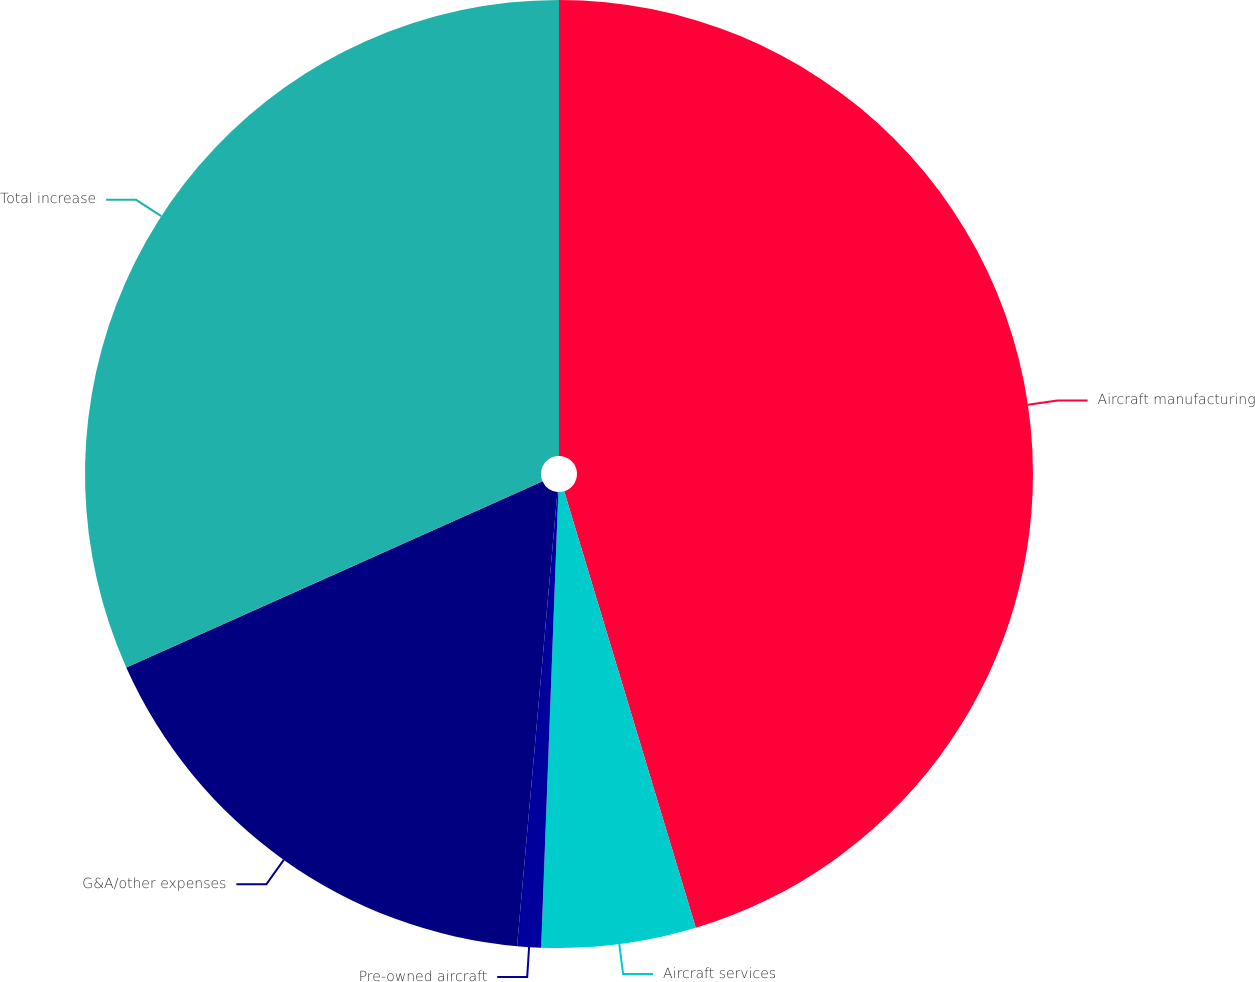Convert chart to OTSL. <chart><loc_0><loc_0><loc_500><loc_500><pie_chart><fcel>Aircraft manufacturing<fcel>Aircraft services<fcel>Pre-owned aircraft<fcel>G&A/other expenses<fcel>Total increase<nl><fcel>45.34%<fcel>5.26%<fcel>0.81%<fcel>16.9%<fcel>31.69%<nl></chart> 